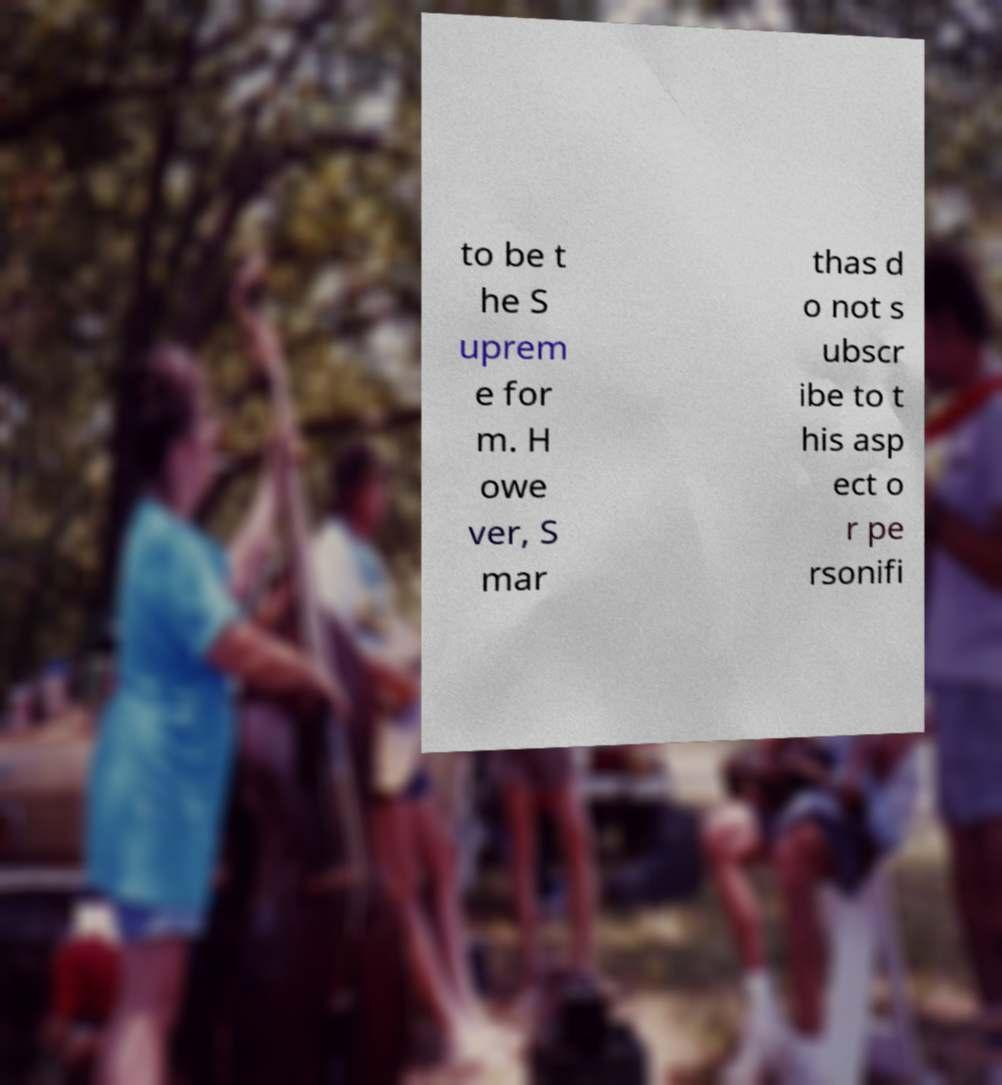Please identify and transcribe the text found in this image. to be t he S uprem e for m. H owe ver, S mar thas d o not s ubscr ibe to t his asp ect o r pe rsonifi 